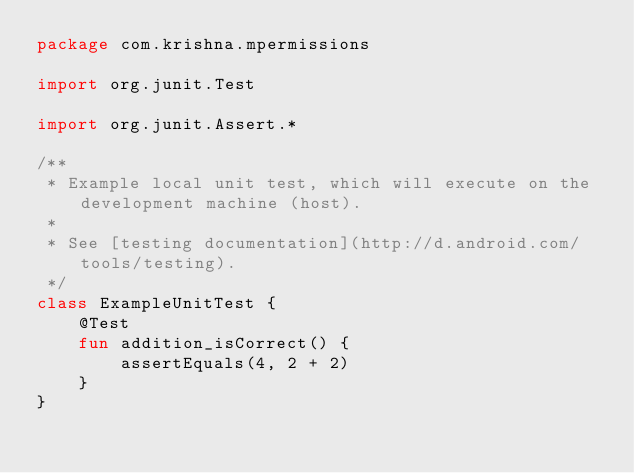<code> <loc_0><loc_0><loc_500><loc_500><_Kotlin_>package com.krishna.mpermissions

import org.junit.Test

import org.junit.Assert.*

/**
 * Example local unit test, which will execute on the development machine (host).
 *
 * See [testing documentation](http://d.android.com/tools/testing).
 */
class ExampleUnitTest {
    @Test
    fun addition_isCorrect() {
        assertEquals(4, 2 + 2)
    }
}
</code> 